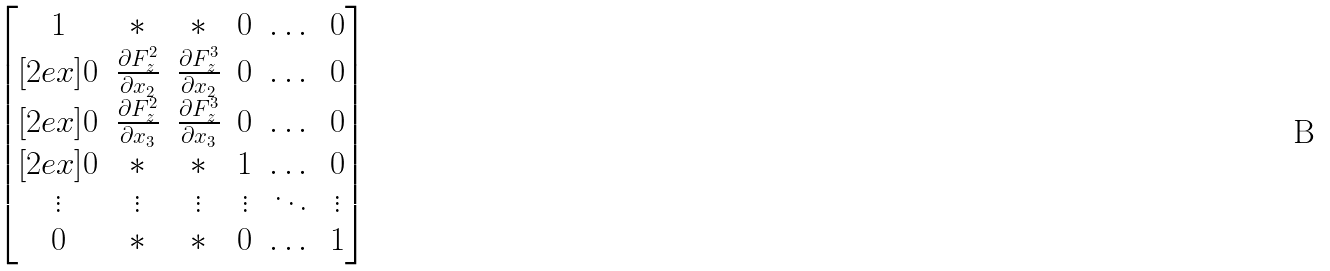Convert formula to latex. <formula><loc_0><loc_0><loc_500><loc_500>\begin{bmatrix} 1 & * & * & 0 & \dots & 0 \\ [ 2 e x ] 0 & \frac { \partial F _ { z } ^ { 2 } } { \partial x _ { 2 } } & \frac { \partial F _ { z } ^ { 3 } } { \partial x _ { 2 } } & 0 & \dots & 0 \\ [ 2 e x ] 0 & \frac { \partial F _ { z } ^ { 2 } } { \partial x _ { 3 } } & \frac { \partial F _ { z } ^ { 3 } } { \partial x _ { 3 } } & 0 & \dots & 0 \\ [ 2 e x ] 0 & * & * & 1 & \dots & 0 \\ \vdots & \vdots & \vdots & \vdots & \ddots & \vdots \\ 0 & * & * & 0 & \dots & 1 \end{bmatrix}</formula> 